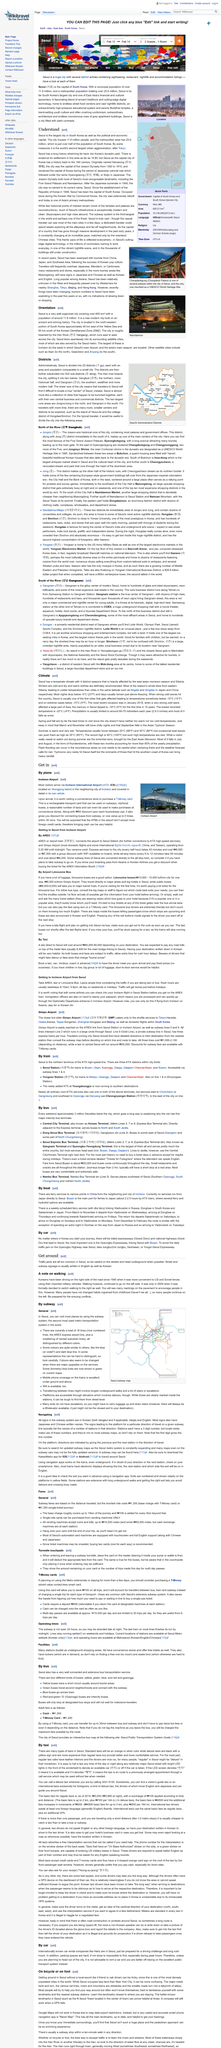Identify some key points in this picture. The city depicted on the map is Seoul. Gangnam is located in the southern region of . Seoul is divided into 25 districts. 